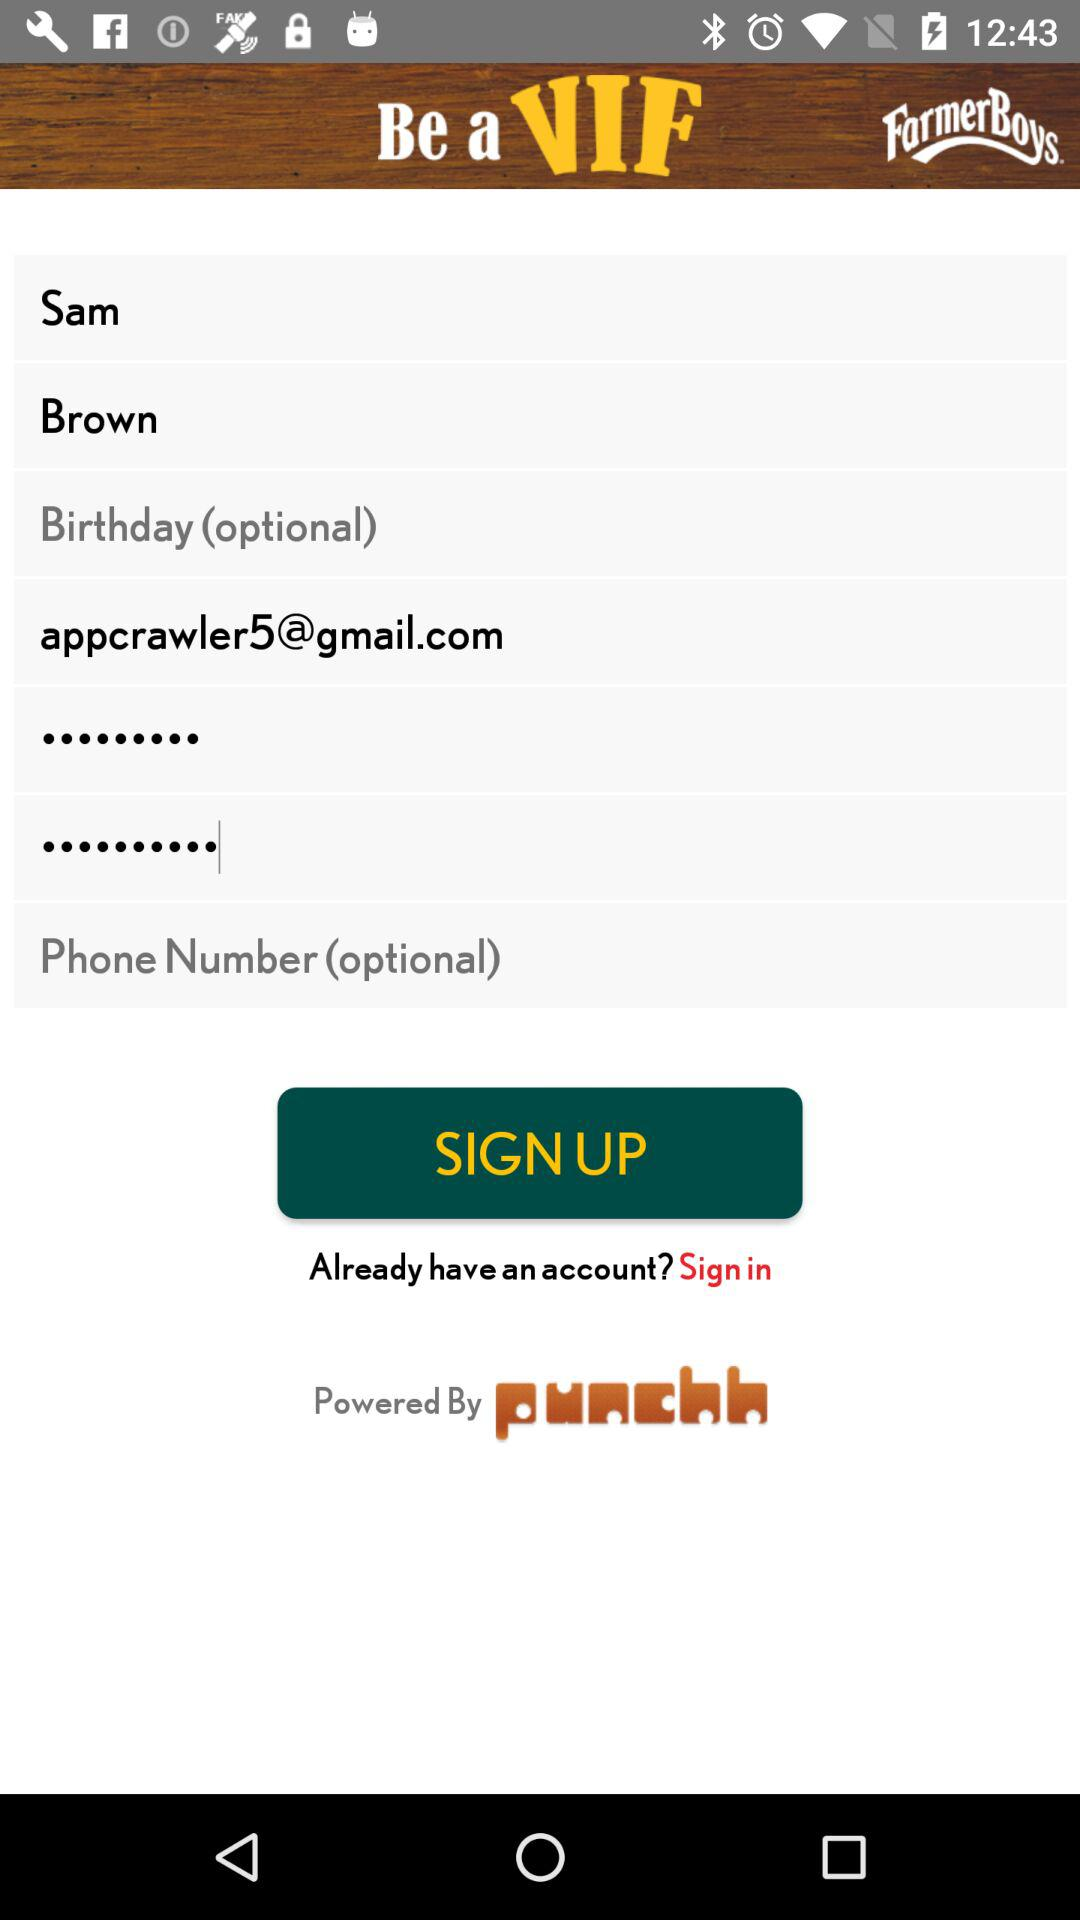Which fields are optional? The optional fields are "Birthday" and "Phone Number". 